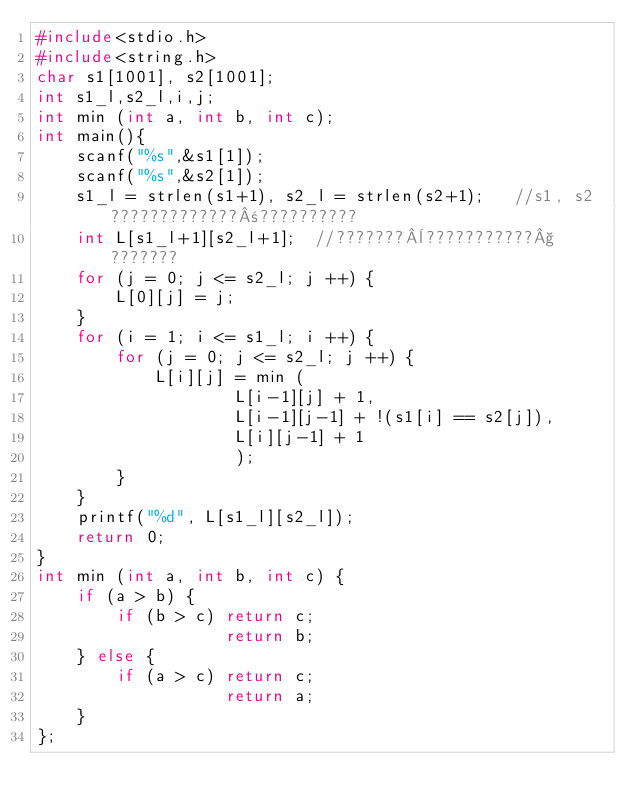Convert code to text. <code><loc_0><loc_0><loc_500><loc_500><_C_>#include<stdio.h>
#include<string.h>
char s1[1001], s2[1001];
int s1_l,s2_l,i,j;
int min (int a, int b, int c);
int main(){
    scanf("%s",&s1[1]);
    scanf("%s",&s2[1]);
    s1_l = strlen(s1+1), s2_l = strlen(s2+1);   //s1, s2?????????????±??????????
    int L[s1_l+1][s2_l+1];  //???????¨???????????§???????
    for (j = 0; j <= s2_l; j ++) {
        L[0][j] = j;
    }
    for (i = 1; i <= s1_l; i ++) {
        for (j = 0; j <= s2_l; j ++) {
            L[i][j] = min (
                    L[i-1][j] + 1,
                    L[i-1][j-1] + !(s1[i] == s2[j]),
                    L[i][j-1] + 1
                    );
        }
    }
    printf("%d", L[s1_l][s2_l]);
    return 0;
}
int min (int a, int b, int c) {
    if (a > b) {
        if (b > c) return c;
                   return b;
    } else {
        if (a > c) return c;
                   return a;
    }
};</code> 